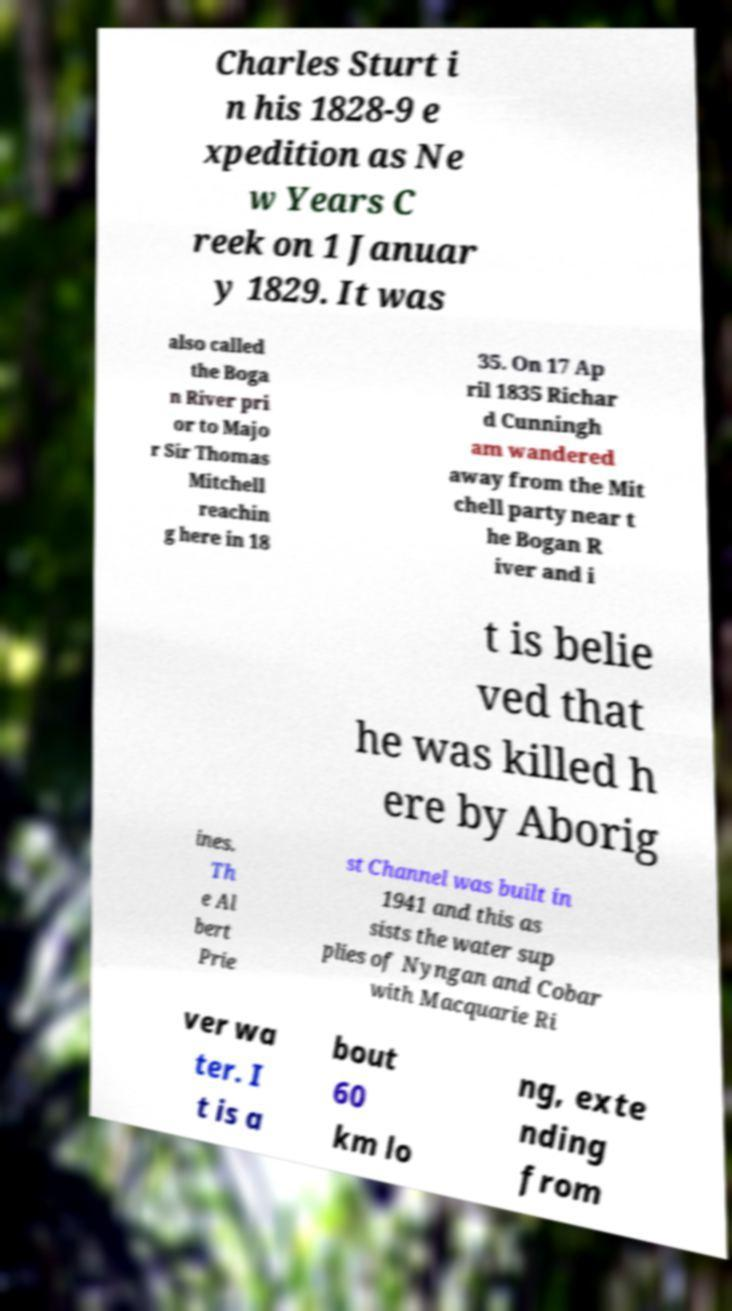Can you accurately transcribe the text from the provided image for me? Charles Sturt i n his 1828-9 e xpedition as Ne w Years C reek on 1 Januar y 1829. It was also called the Boga n River pri or to Majo r Sir Thomas Mitchell reachin g here in 18 35. On 17 Ap ril 1835 Richar d Cunningh am wandered away from the Mit chell party near t he Bogan R iver and i t is belie ved that he was killed h ere by Aborig ines. Th e Al bert Prie st Channel was built in 1941 and this as sists the water sup plies of Nyngan and Cobar with Macquarie Ri ver wa ter. I t is a bout 60 km lo ng, exte nding from 